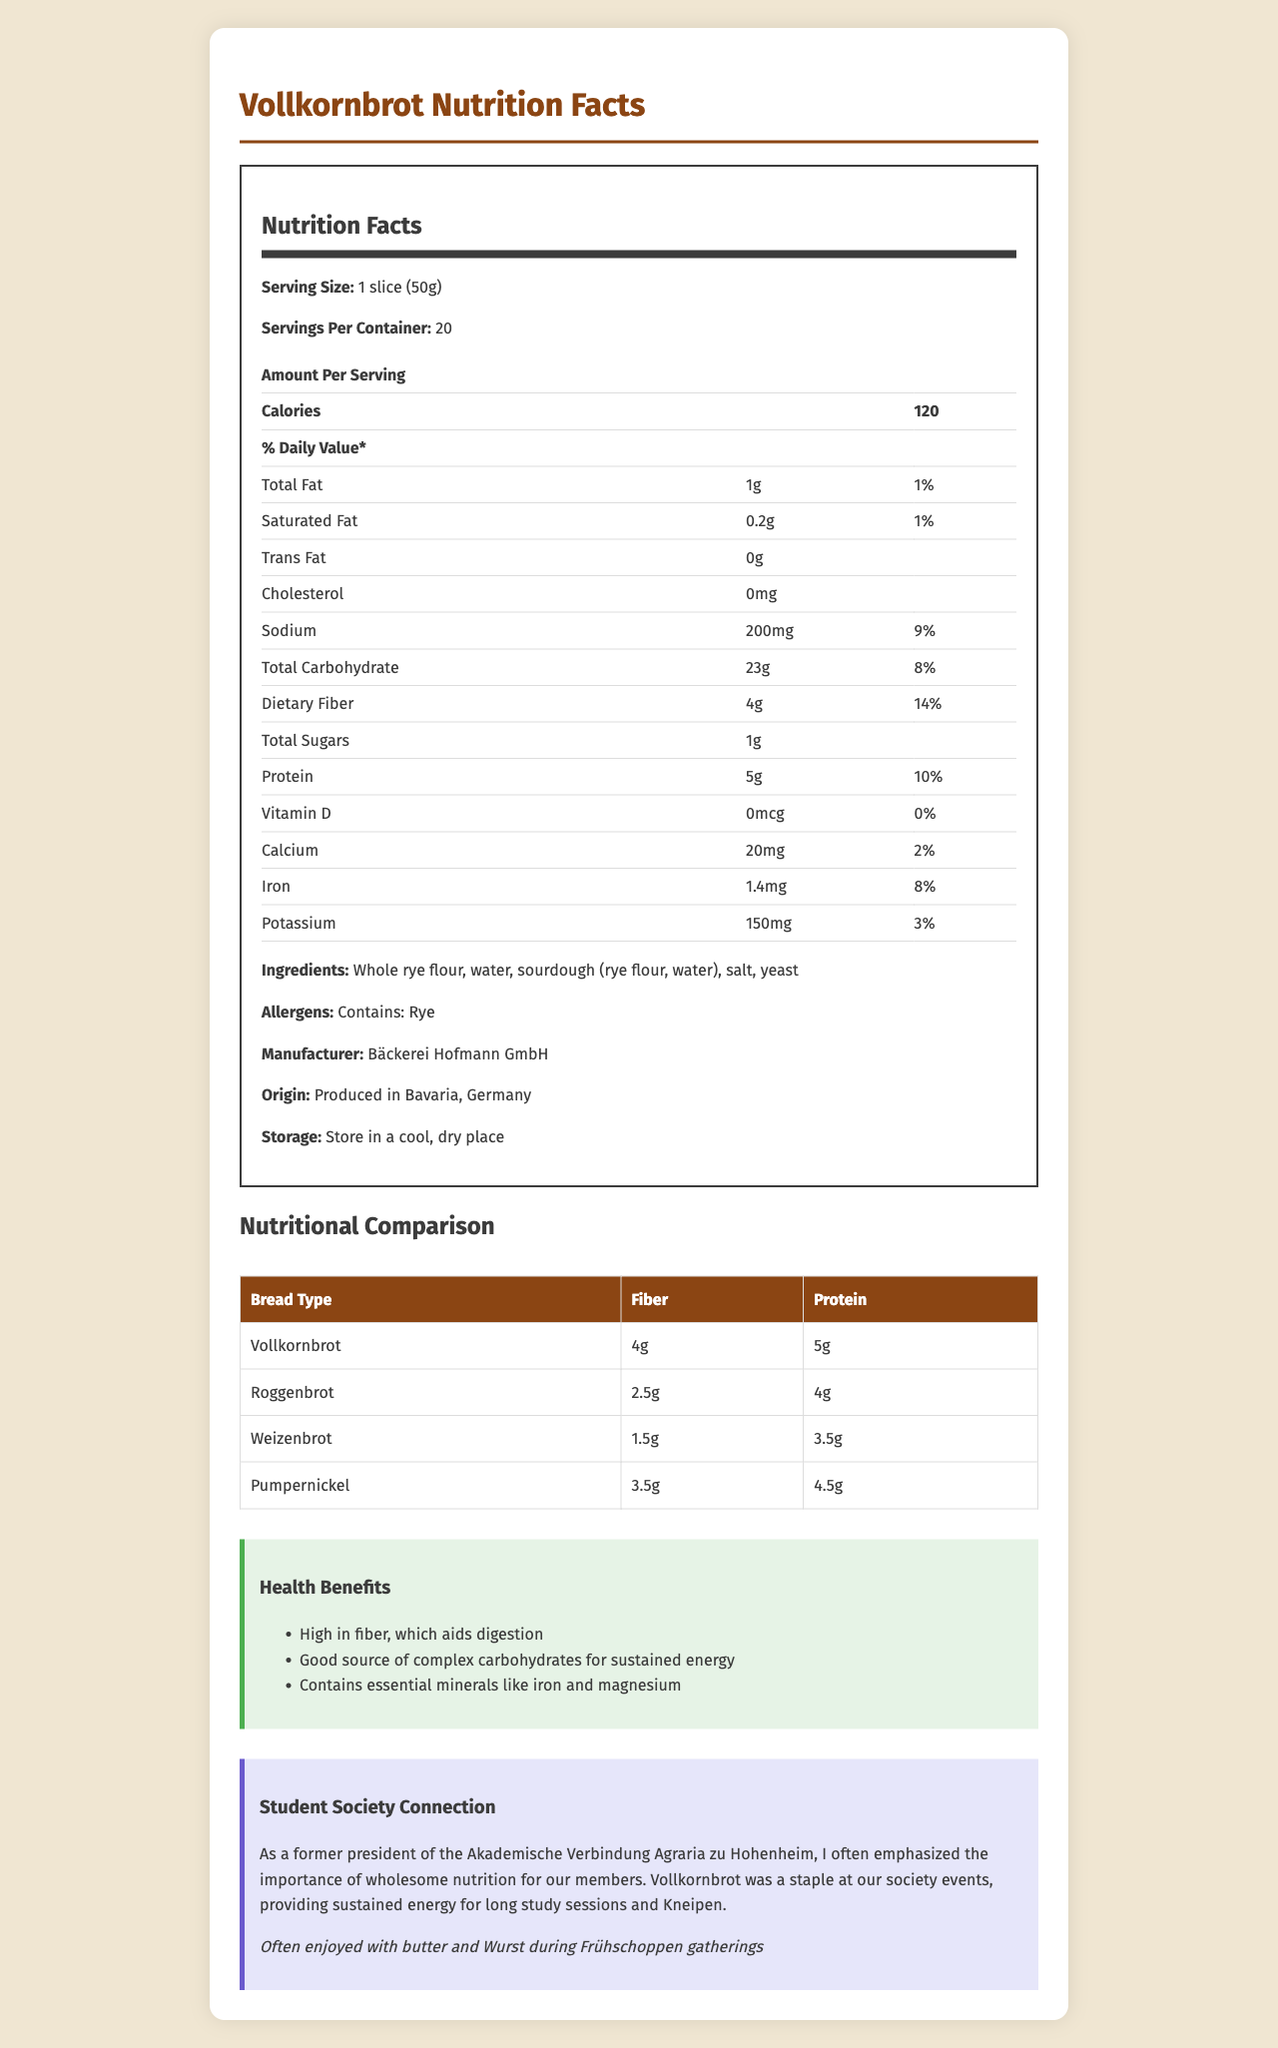what is the serving size of Vollkornbrot? The serving size is listed as "1 slice (50g)" in the nutrition label.
Answer: 1 slice (50g) how many servings are there per container of Vollkornbrot? The document states that there are 20 servings per container.
Answer: 20 what is the amount of dietary fiber per serving of Vollkornbrot? The nutritional label specifies that there are 4g of dietary fiber per serving.
Answer: 4g how much protein does one serving of Vollkornbrot contain? According to the label, one serving contains 5g of protein.
Answer: 5g what is the daily value percentage of iron in one serving of Vollkornbrot? The label shows that one serving has an 8% daily value of iron.
Answer: 8% which type of bread has the highest fiber content? 
A. Vollkornbrot
B. Roggenbrot
C. Weizenbrot
D. Pumpernickel Vollkornbrot has the highest fiber content at 4g compared to Roggenbrot (2.5g), Weizenbrot (1.5g), and Pumpernickel (3.5g).
Answer: A which type of bread provides the least protein?
I. Vollkornbrot
II. Roggenbrot
III. Weizenbrot
IV. Pumpernickel Weizenbrot provides the least protein at 3.5g compared to Vollkornbrot (5g), Roggenbrot (4g), and Pumpernickel (4.5g).
Answer: III is the cholesterol content of Vollkornbrot high? The document indicates that the cholesterol content is 0mg, which is negligible.
Answer: No explain the main idea of the nutrition facts label for Vollkornbrot. The main idea is to inform consumers about the nutritional value and health benefits of consuming Vollkornbrot while contrasting it with other types of bread. Additionally, it sheds light on the traditional significance of Vollkornbrot within a student society context in Germany.
Answer: The nutrition facts label provides detailed information on the nutritional content of Vollkornbrot, including serving size, calorie count, macronutrients, vitamins, minerals, and the percentage of daily values. It also compares the fiber and protein content to other German bread varieties, highlights health benefits, and shares its traditional consumption context related to a student society. what is the origin of Vollkornbrot? The document provides the origin as "Produced in Bavaria, Germany."
Answer: Produced in Bavaria, Germany does Vollkornbrot contain any allergens? The document states that Vollkornbrot contains rye as an allergen.
Answer: Yes what are the traditional consumption habits of Vollkornbrot? The document mentions that Vollkornbrot is traditionally consumed with butter and Wurst during Frühschoppen gatherings.
Answer: Often enjoyed with butter and Wurst during Frühschoppen gatherings how much saturated fat is in one serving of Vollkornbrot? The nutrition label indicates that one serving contains 0.2g of saturated fat.
Answer: 0.2g what is the fiber content of Roggenbrot? The nutritional comparison section lists Roggenbrot as having 2.5g of fiber.
Answer: 2.5g what is the protein content of Weizenbrot? According to the nutritional comparison, Weizenbrot contains 3.5g of protein.
Answer: 3.5g what is the amount of calcium in one serving of Vollkornbrot? The nutritional label lists 20mg of calcium per serving.
Answer: 20mg who is the manufacturer of Vollkornbrot? The document specifies the manufacturer as Bäckerei Hofmann GmbH.
Answer: Bäckerei Hofmann GmbH is there any information about the vitamin C content of Vollkornbrot? The document does not provide any information regarding the vitamin C content of Vollkornbrot.
Answer: Cannot be determined 